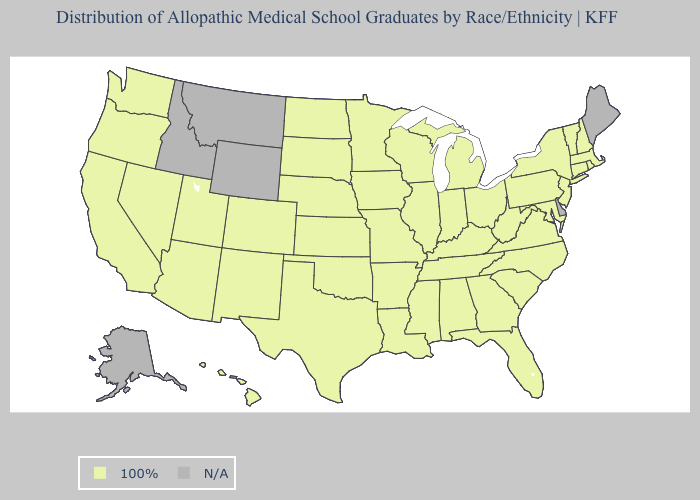Name the states that have a value in the range 100%?
Answer briefly. Alabama, Arizona, Arkansas, California, Colorado, Connecticut, Florida, Georgia, Hawaii, Illinois, Indiana, Iowa, Kansas, Kentucky, Louisiana, Maryland, Massachusetts, Michigan, Minnesota, Mississippi, Missouri, Nebraska, Nevada, New Hampshire, New Jersey, New Mexico, New York, North Carolina, North Dakota, Ohio, Oklahoma, Oregon, Pennsylvania, Rhode Island, South Carolina, South Dakota, Tennessee, Texas, Utah, Vermont, Virginia, Washington, West Virginia, Wisconsin. What is the value of West Virginia?
Write a very short answer. 100%. What is the lowest value in the USA?
Be succinct. 100%. Name the states that have a value in the range N/A?
Write a very short answer. Alaska, Delaware, Idaho, Maine, Montana, Wyoming. Name the states that have a value in the range 100%?
Answer briefly. Alabama, Arizona, Arkansas, California, Colorado, Connecticut, Florida, Georgia, Hawaii, Illinois, Indiana, Iowa, Kansas, Kentucky, Louisiana, Maryland, Massachusetts, Michigan, Minnesota, Mississippi, Missouri, Nebraska, Nevada, New Hampshire, New Jersey, New Mexico, New York, North Carolina, North Dakota, Ohio, Oklahoma, Oregon, Pennsylvania, Rhode Island, South Carolina, South Dakota, Tennessee, Texas, Utah, Vermont, Virginia, Washington, West Virginia, Wisconsin. Name the states that have a value in the range N/A?
Concise answer only. Alaska, Delaware, Idaho, Maine, Montana, Wyoming. Name the states that have a value in the range 100%?
Quick response, please. Alabama, Arizona, Arkansas, California, Colorado, Connecticut, Florida, Georgia, Hawaii, Illinois, Indiana, Iowa, Kansas, Kentucky, Louisiana, Maryland, Massachusetts, Michigan, Minnesota, Mississippi, Missouri, Nebraska, Nevada, New Hampshire, New Jersey, New Mexico, New York, North Carolina, North Dakota, Ohio, Oklahoma, Oregon, Pennsylvania, Rhode Island, South Carolina, South Dakota, Tennessee, Texas, Utah, Vermont, Virginia, Washington, West Virginia, Wisconsin. Is the legend a continuous bar?
Be succinct. No. What is the value of Nevada?
Be succinct. 100%. Name the states that have a value in the range N/A?
Write a very short answer. Alaska, Delaware, Idaho, Maine, Montana, Wyoming. What is the value of Louisiana?
Be succinct. 100%. 